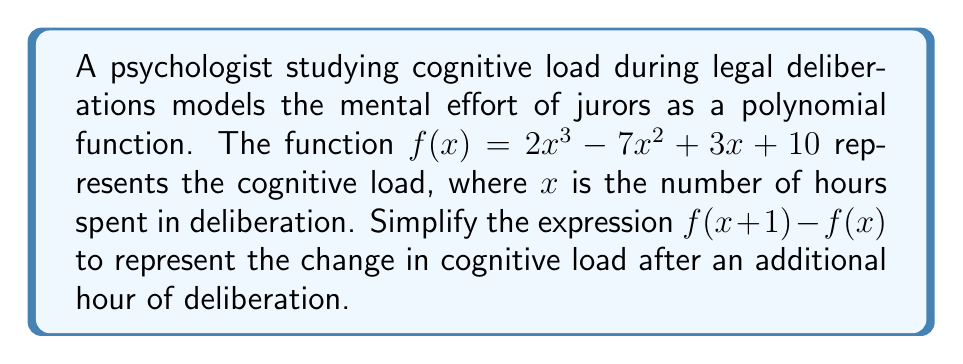Can you solve this math problem? To simplify $f(x+1) - f(x)$, we need to follow these steps:

1) First, let's expand $f(x+1)$:

   $f(x+1) = 2(x+1)^3 - 7(x+1)^2 + 3(x+1) + 10$

2) Expand each term:

   $2(x+1)^3 = 2(x^3 + 3x^2 + 3x + 1)$
   $-7(x+1)^2 = -7(x^2 + 2x + 1)$
   $3(x+1) = 3x + 3$

3) Combine like terms:

   $f(x+1) = 2x^3 + 6x^2 + 6x + 2 - 7x^2 - 14x - 7 + 3x + 3 + 10$
   $f(x+1) = 2x^3 - x^2 - 5x + 8$

4) Now subtract $f(x)$ from $f(x+1)$:

   $f(x+1) - f(x) = (2x^3 - x^2 - 5x + 8) - (2x^3 - 7x^2 + 3x + 10)$

5) Simplify:

   $f(x+1) - f(x) = 2x^3 - x^2 - 5x + 8 - 2x^3 + 7x^2 - 3x - 10$
   $f(x+1) - f(x) = 6x^2 - 8x - 2$

This simplified expression represents the change in cognitive load after an additional hour of deliberation.
Answer: $f(x+1) - f(x) = 6x^2 - 8x - 2$ 